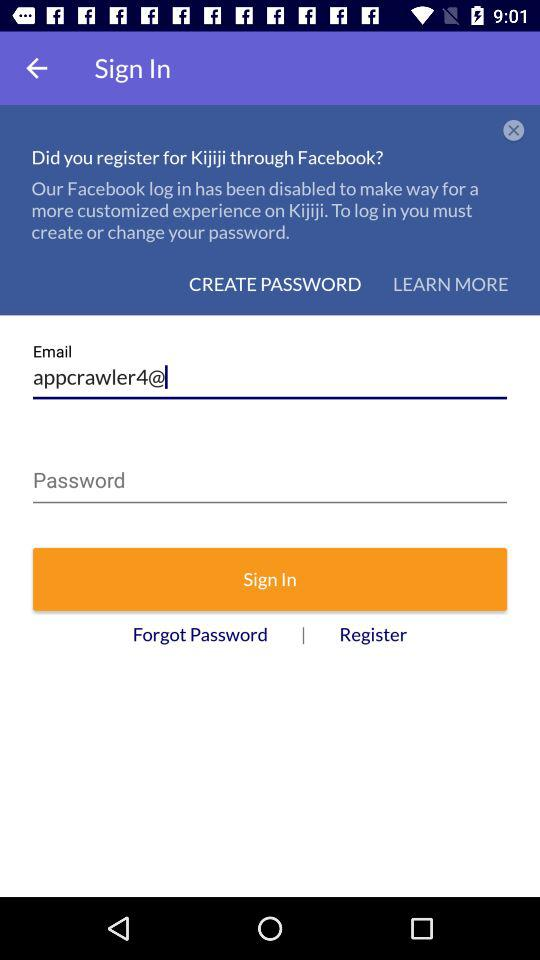What is the given country's name? The given country's name is Canada. 